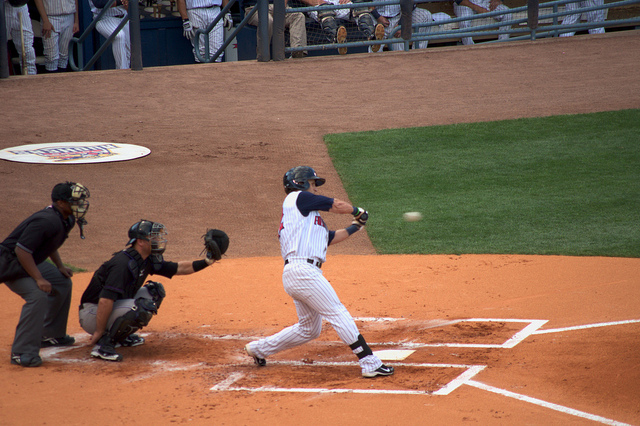What equipment do the players have? The batter is holding a baseball bat, which is used to hit the ball. The catcher has a mitt for catching pitches and protective gear that includes a helmet, face mask, chest protector, and shin guards. 